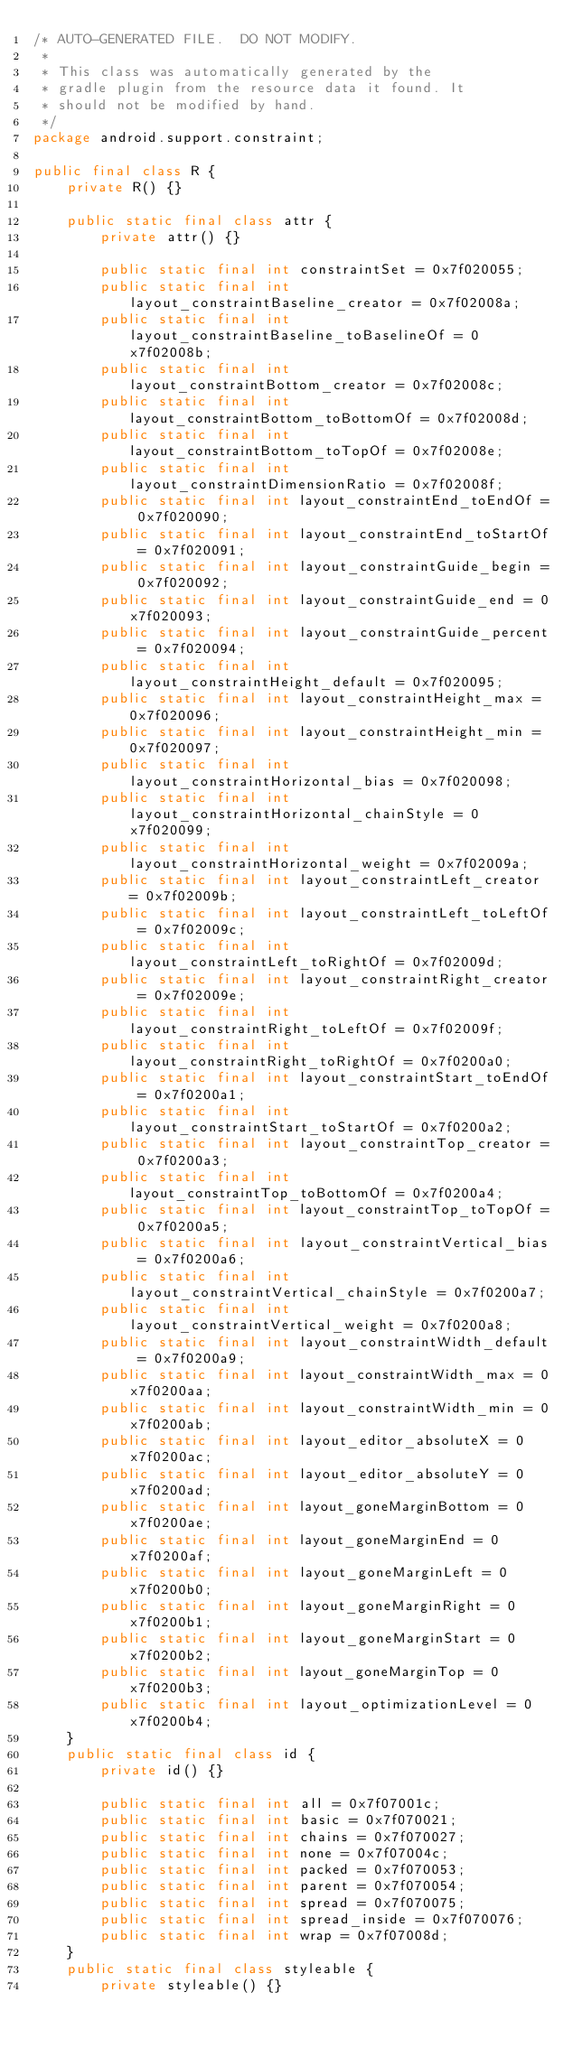Convert code to text. <code><loc_0><loc_0><loc_500><loc_500><_Java_>/* AUTO-GENERATED FILE.  DO NOT MODIFY.
 *
 * This class was automatically generated by the
 * gradle plugin from the resource data it found. It
 * should not be modified by hand.
 */
package android.support.constraint;

public final class R {
    private R() {}

    public static final class attr {
        private attr() {}

        public static final int constraintSet = 0x7f020055;
        public static final int layout_constraintBaseline_creator = 0x7f02008a;
        public static final int layout_constraintBaseline_toBaselineOf = 0x7f02008b;
        public static final int layout_constraintBottom_creator = 0x7f02008c;
        public static final int layout_constraintBottom_toBottomOf = 0x7f02008d;
        public static final int layout_constraintBottom_toTopOf = 0x7f02008e;
        public static final int layout_constraintDimensionRatio = 0x7f02008f;
        public static final int layout_constraintEnd_toEndOf = 0x7f020090;
        public static final int layout_constraintEnd_toStartOf = 0x7f020091;
        public static final int layout_constraintGuide_begin = 0x7f020092;
        public static final int layout_constraintGuide_end = 0x7f020093;
        public static final int layout_constraintGuide_percent = 0x7f020094;
        public static final int layout_constraintHeight_default = 0x7f020095;
        public static final int layout_constraintHeight_max = 0x7f020096;
        public static final int layout_constraintHeight_min = 0x7f020097;
        public static final int layout_constraintHorizontal_bias = 0x7f020098;
        public static final int layout_constraintHorizontal_chainStyle = 0x7f020099;
        public static final int layout_constraintHorizontal_weight = 0x7f02009a;
        public static final int layout_constraintLeft_creator = 0x7f02009b;
        public static final int layout_constraintLeft_toLeftOf = 0x7f02009c;
        public static final int layout_constraintLeft_toRightOf = 0x7f02009d;
        public static final int layout_constraintRight_creator = 0x7f02009e;
        public static final int layout_constraintRight_toLeftOf = 0x7f02009f;
        public static final int layout_constraintRight_toRightOf = 0x7f0200a0;
        public static final int layout_constraintStart_toEndOf = 0x7f0200a1;
        public static final int layout_constraintStart_toStartOf = 0x7f0200a2;
        public static final int layout_constraintTop_creator = 0x7f0200a3;
        public static final int layout_constraintTop_toBottomOf = 0x7f0200a4;
        public static final int layout_constraintTop_toTopOf = 0x7f0200a5;
        public static final int layout_constraintVertical_bias = 0x7f0200a6;
        public static final int layout_constraintVertical_chainStyle = 0x7f0200a7;
        public static final int layout_constraintVertical_weight = 0x7f0200a8;
        public static final int layout_constraintWidth_default = 0x7f0200a9;
        public static final int layout_constraintWidth_max = 0x7f0200aa;
        public static final int layout_constraintWidth_min = 0x7f0200ab;
        public static final int layout_editor_absoluteX = 0x7f0200ac;
        public static final int layout_editor_absoluteY = 0x7f0200ad;
        public static final int layout_goneMarginBottom = 0x7f0200ae;
        public static final int layout_goneMarginEnd = 0x7f0200af;
        public static final int layout_goneMarginLeft = 0x7f0200b0;
        public static final int layout_goneMarginRight = 0x7f0200b1;
        public static final int layout_goneMarginStart = 0x7f0200b2;
        public static final int layout_goneMarginTop = 0x7f0200b3;
        public static final int layout_optimizationLevel = 0x7f0200b4;
    }
    public static final class id {
        private id() {}

        public static final int all = 0x7f07001c;
        public static final int basic = 0x7f070021;
        public static final int chains = 0x7f070027;
        public static final int none = 0x7f07004c;
        public static final int packed = 0x7f070053;
        public static final int parent = 0x7f070054;
        public static final int spread = 0x7f070075;
        public static final int spread_inside = 0x7f070076;
        public static final int wrap = 0x7f07008d;
    }
    public static final class styleable {
        private styleable() {}
</code> 